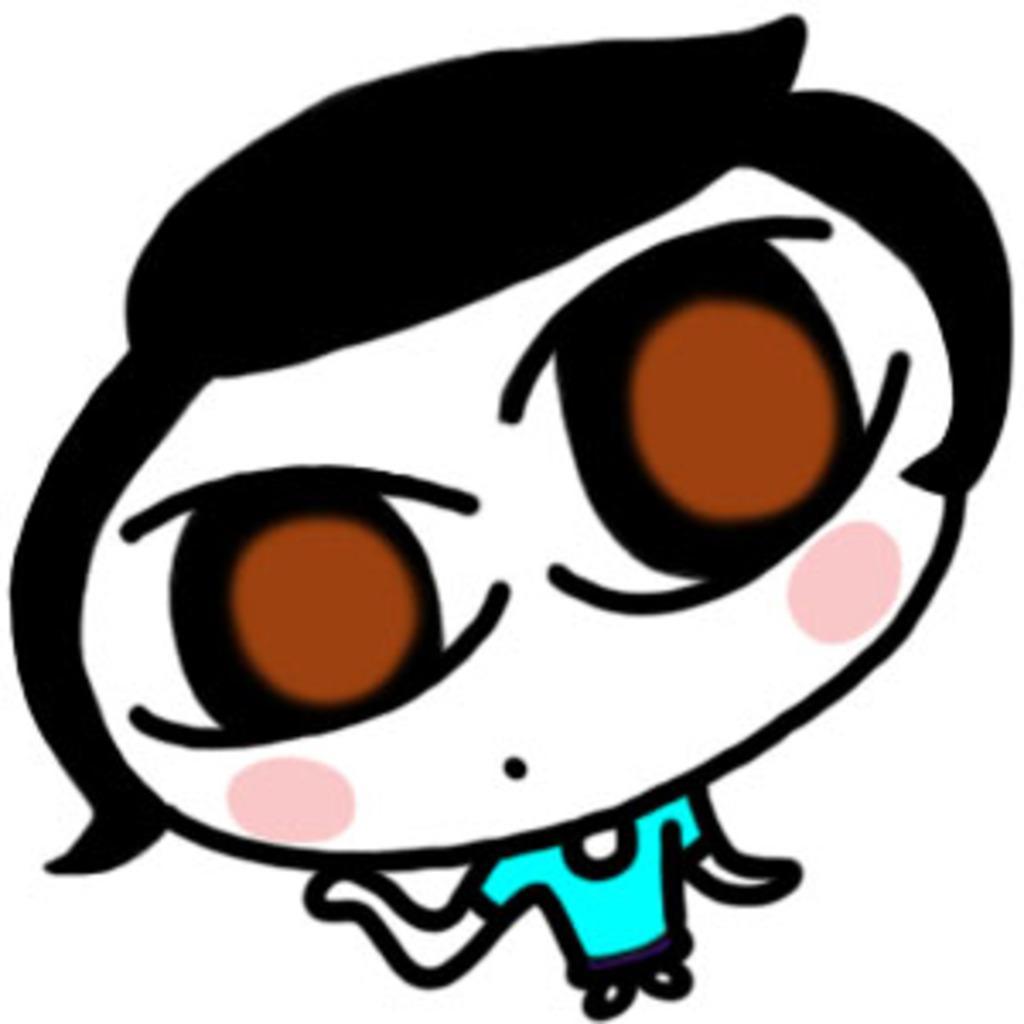Can you describe this image briefly? It is an animated image of a person. This person wore blue color t-shirt. 